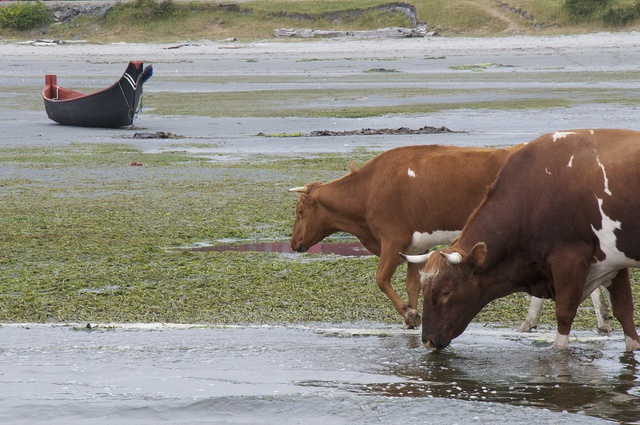Describe the objects in this image and their specific colors. I can see cow in black, maroon, brown, and gray tones, cow in black, brown, and maroon tones, and boat in black, gray, and brown tones in this image. 